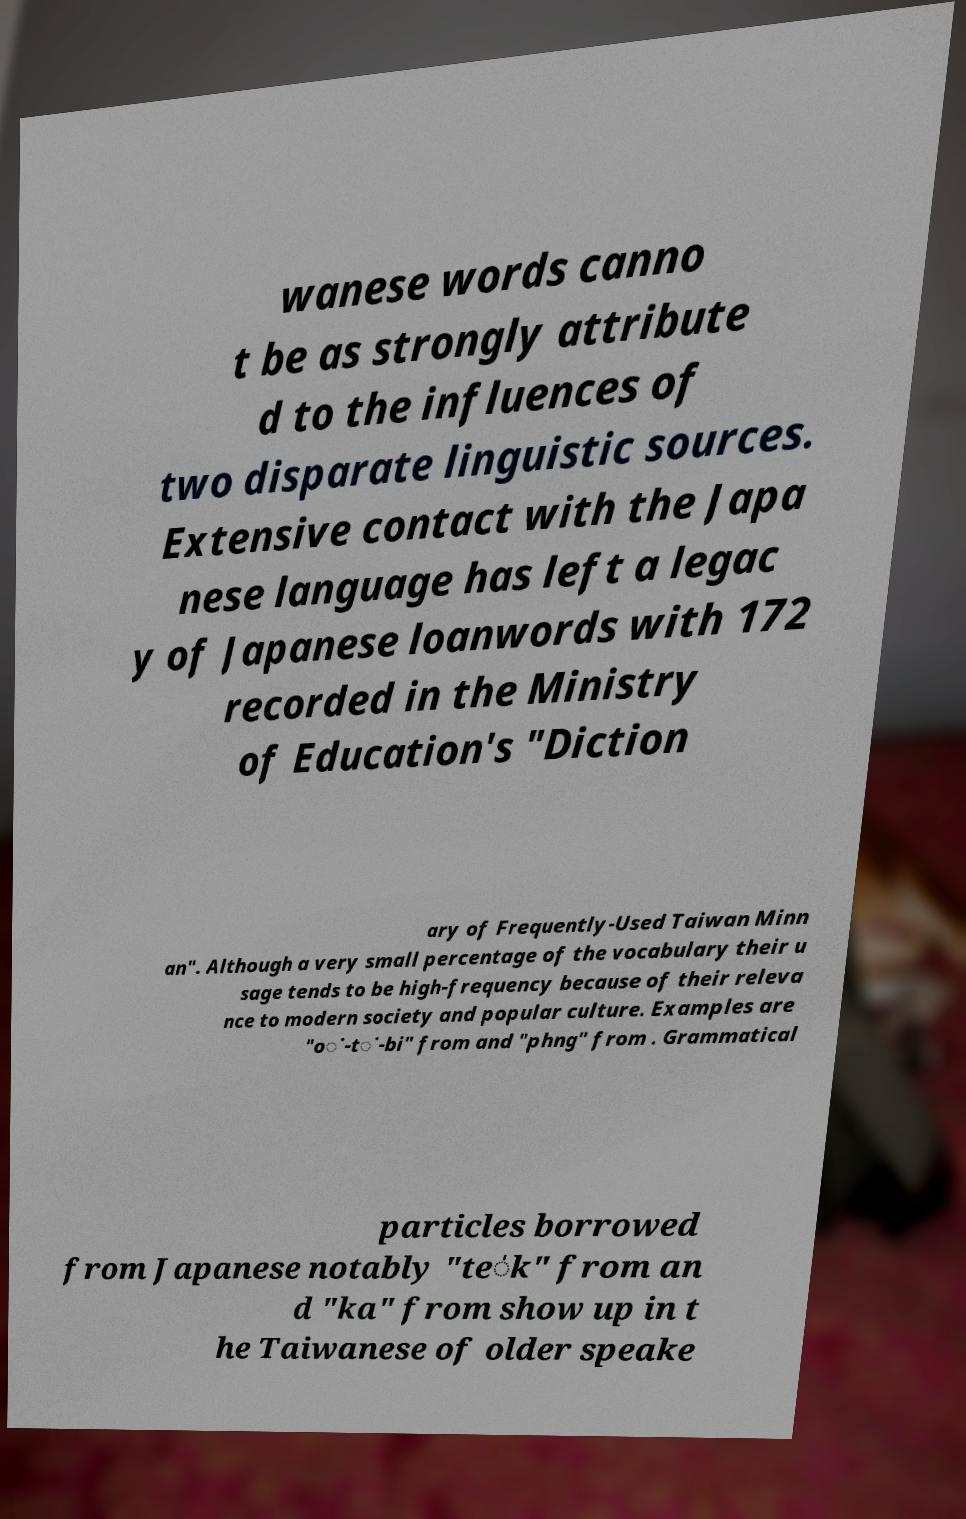There's text embedded in this image that I need extracted. Can you transcribe it verbatim? wanese words canno t be as strongly attribute d to the influences of two disparate linguistic sources. Extensive contact with the Japa nese language has left a legac y of Japanese loanwords with 172 recorded in the Ministry of Education's "Diction ary of Frequently-Used Taiwan Minn an". Although a very small percentage of the vocabulary their u sage tends to be high-frequency because of their releva nce to modern society and popular culture. Examples are "o͘-t͘-bi" from and "phng" from . Grammatical particles borrowed from Japanese notably "te̍k" from an d "ka" from show up in t he Taiwanese of older speake 